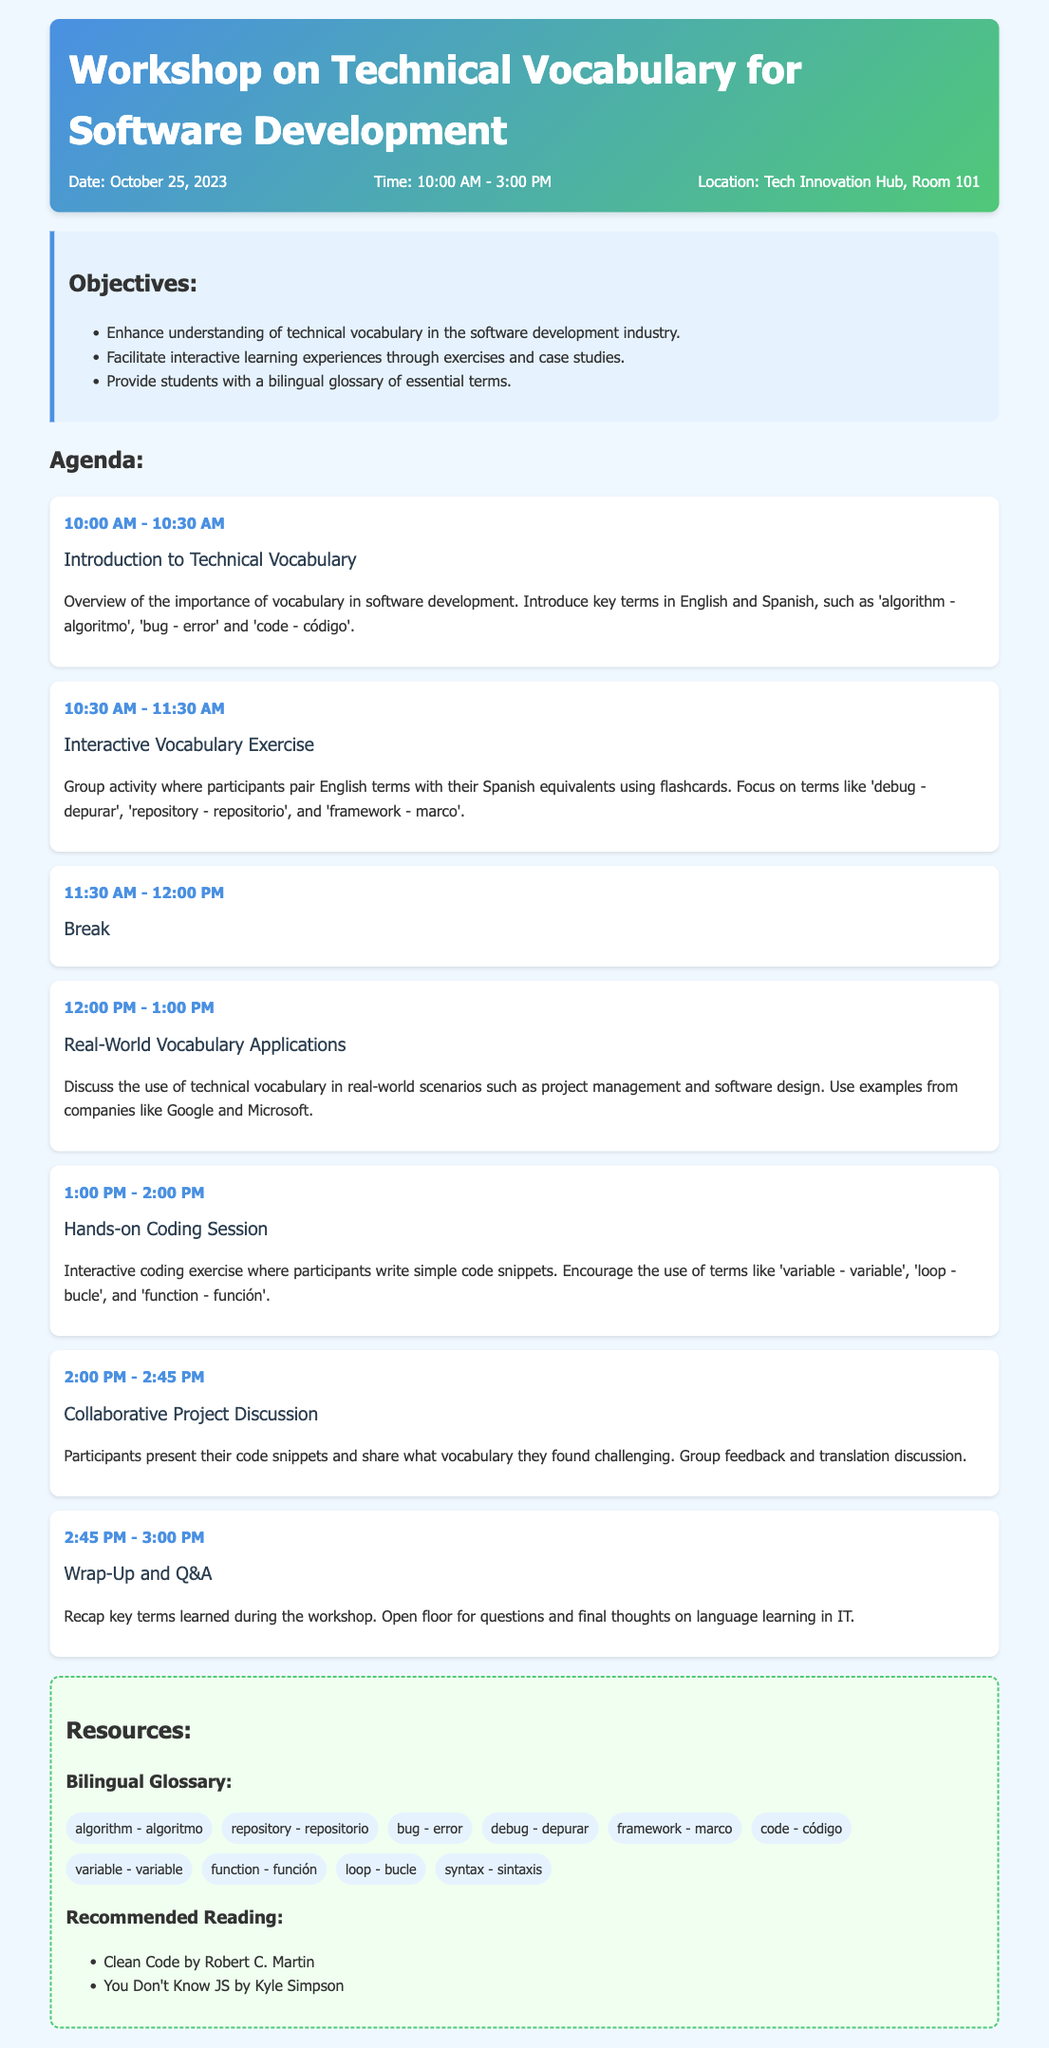What is the date of the workshop? The workshop is scheduled for October 25, 2023, as stated in the document.
Answer: October 25, 2023 What is the duration of the workshop? The workshop runs from 10:00 AM to 3:00 PM, which can be found in the workshop details.
Answer: 5 hours What is the location of the workshop? The specific location is given in the document as the Tech Innovation Hub, Room 101.
Answer: Tech Innovation Hub, Room 101 What is one of the key terms introduced in the introduction session? The document lists key terms such as 'algorithm - algoritmo' as part of the introduction to technical vocabulary.
Answer: algorithm - algoritmo What activity is scheduled immediately after the introduction? The agenda clearly states that an Interactive Vocabulary Exercise follows the introduction session.
Answer: Interactive Vocabulary Exercise What company is mentioned during the real-world applications discussion? The document refers to Google as an example during the discussion on technical vocabulary applications.
Answer: Google How long is the break during the workshop? The break is outlined in the agenda as lasting for 30 minutes.
Answer: 30 minutes What type of session occurs at 1:00 PM? The agenda specifies that a Hands-on Coding Session occurs at this time.
Answer: Hands-on Coding Session What is one resource mentioned in the recommended reading? One of the books listed under recommended reading is "Clean Code by Robert C. Martin."
Answer: Clean Code by Robert C. Martin 